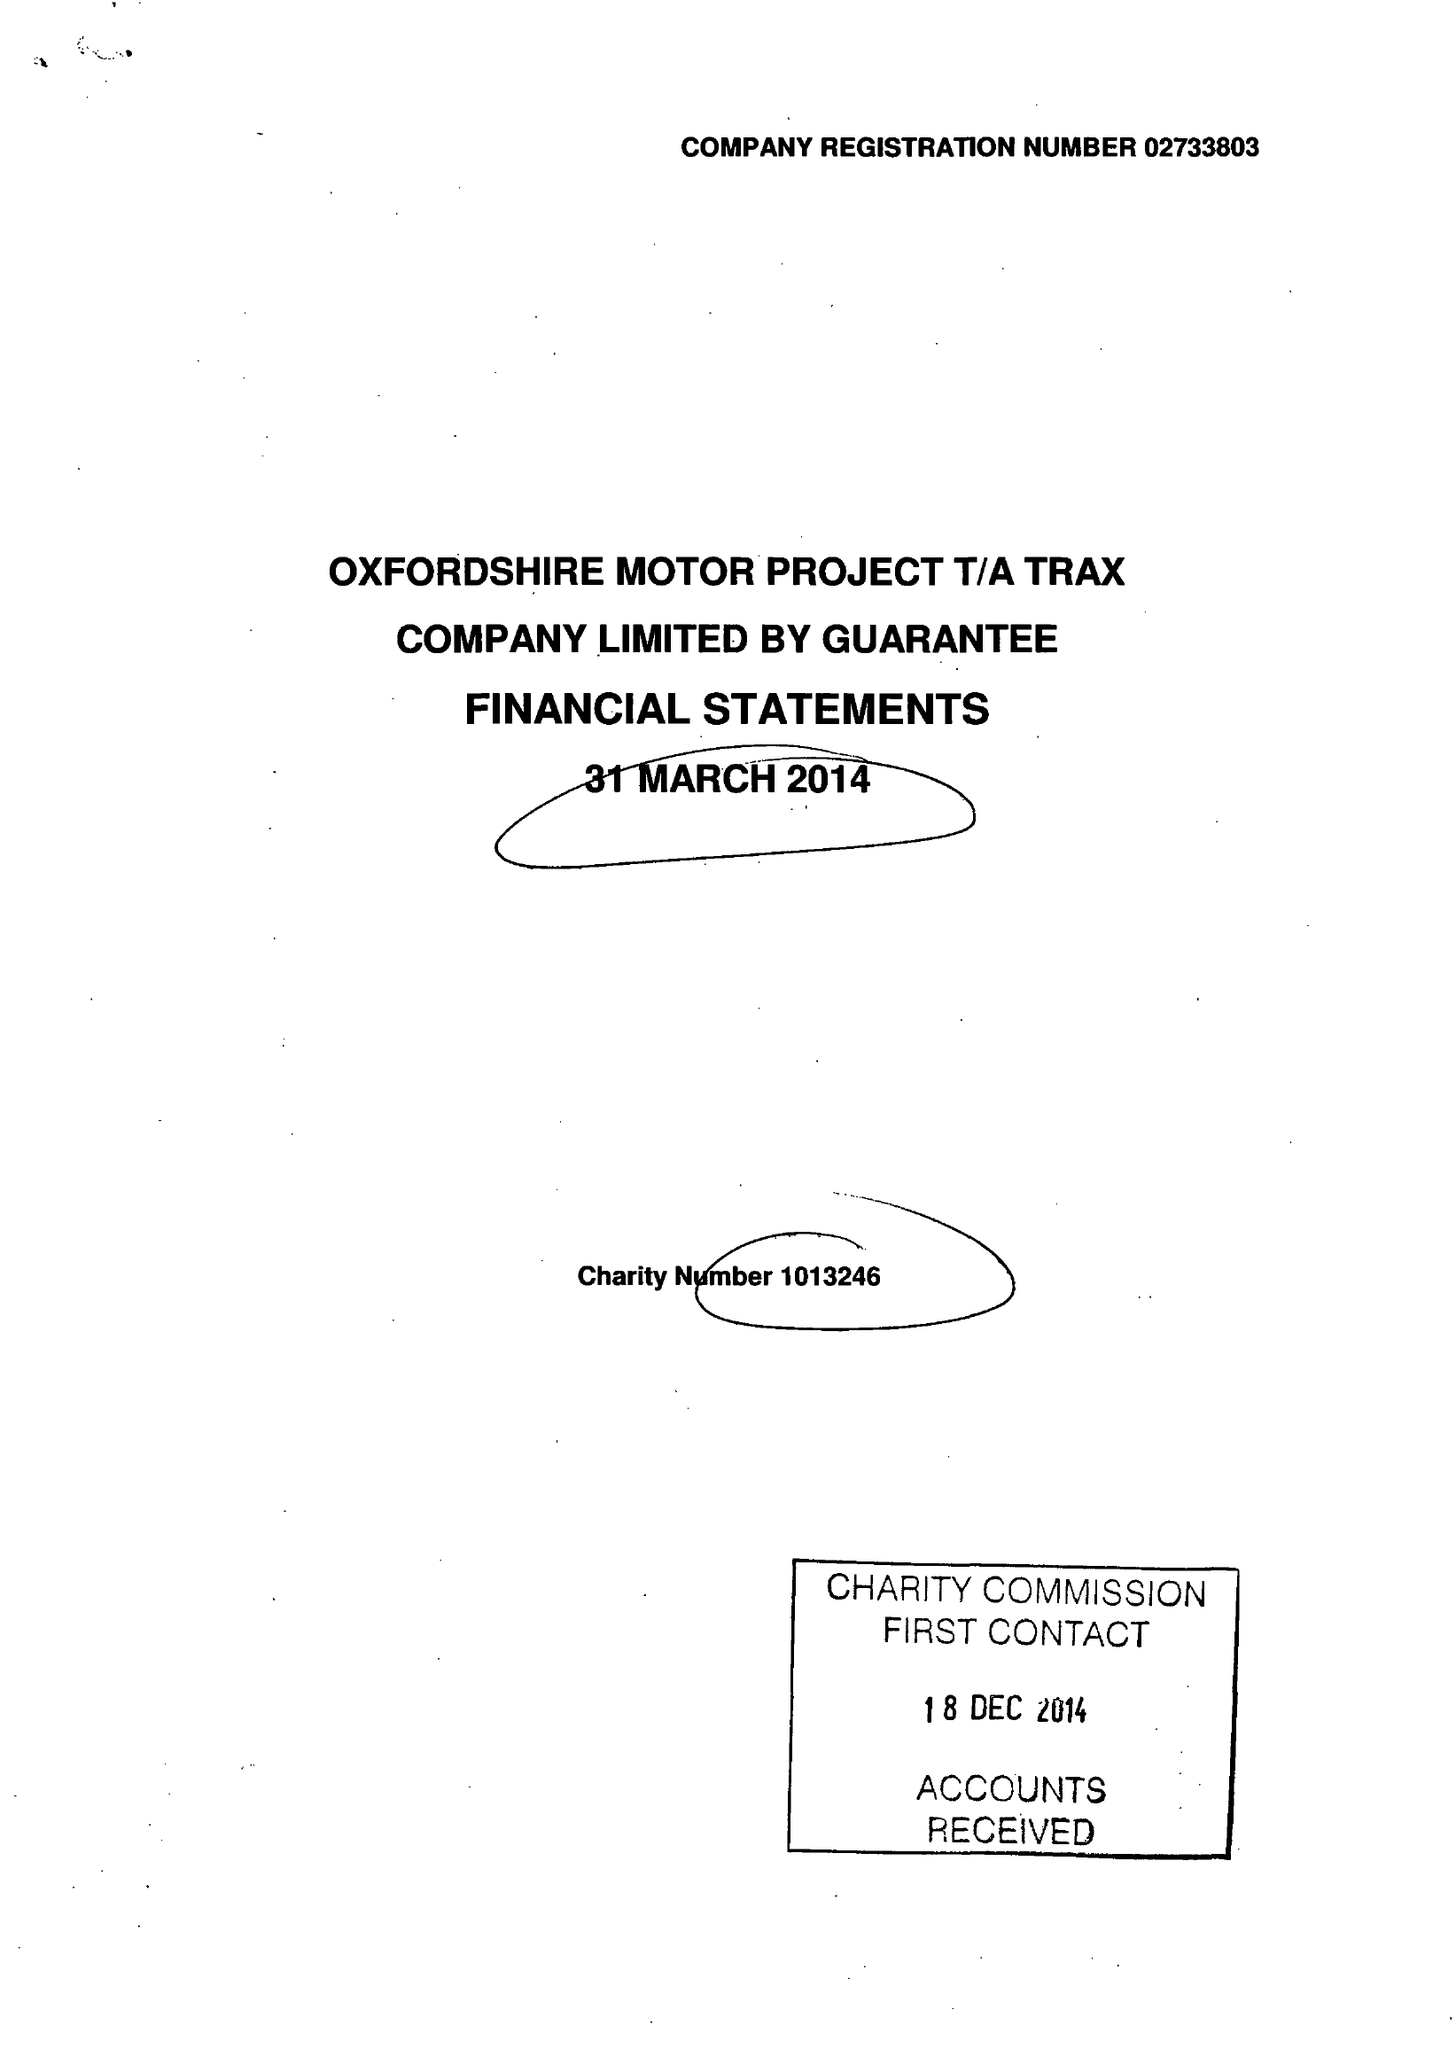What is the value for the address__post_town?
Answer the question using a single word or phrase. OXFORD 